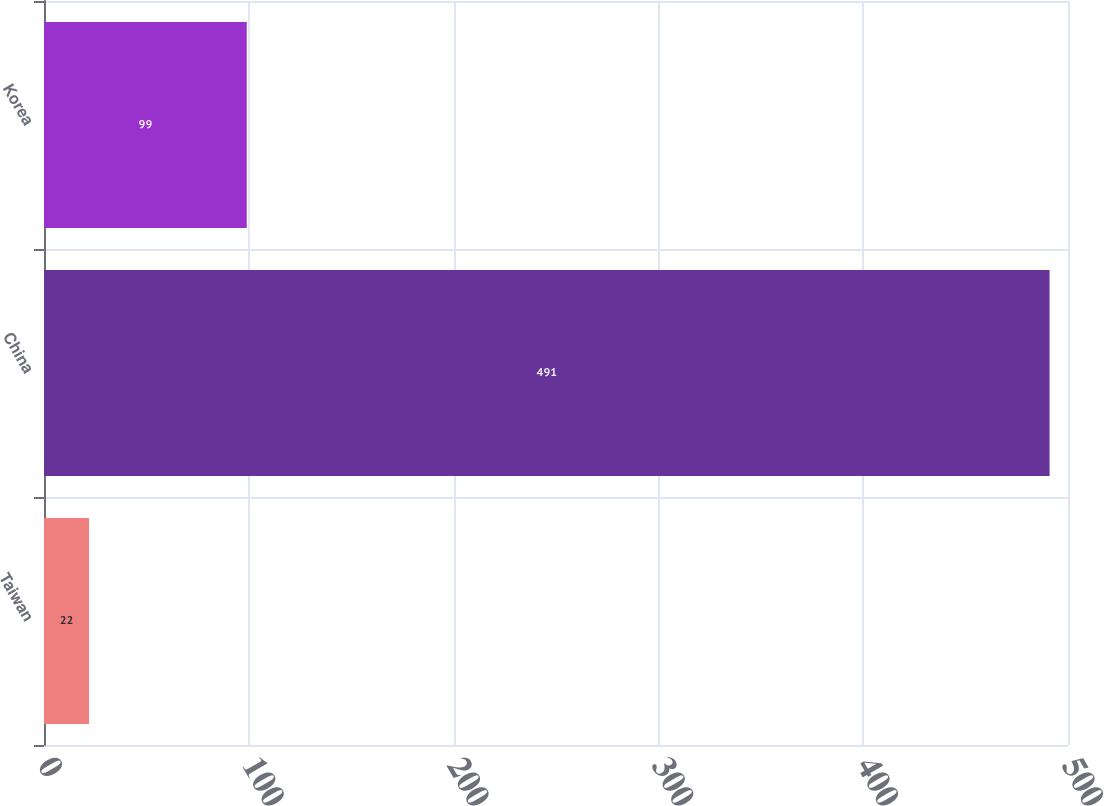Convert chart. <chart><loc_0><loc_0><loc_500><loc_500><bar_chart><fcel>Taiwan<fcel>China<fcel>Korea<nl><fcel>22<fcel>491<fcel>99<nl></chart> 